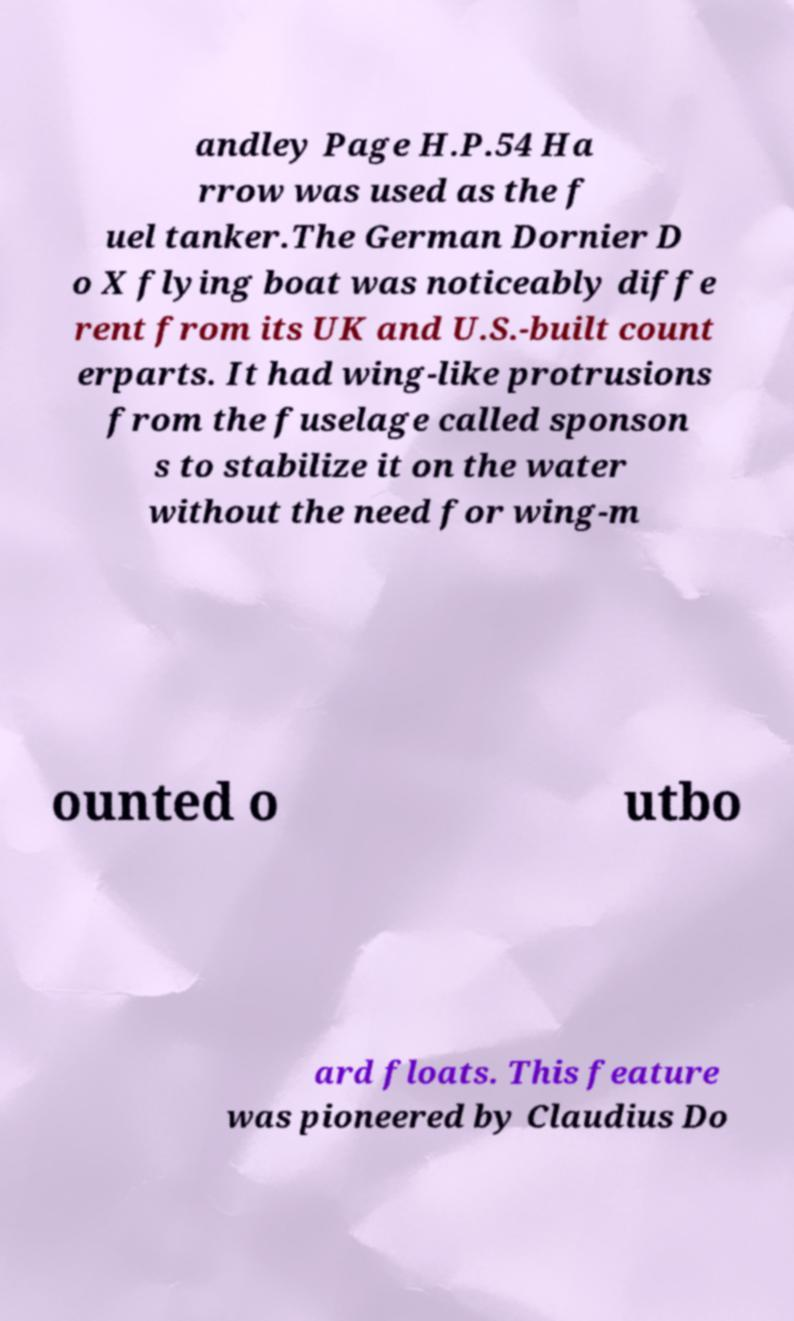Could you extract and type out the text from this image? andley Page H.P.54 Ha rrow was used as the f uel tanker.The German Dornier D o X flying boat was noticeably diffe rent from its UK and U.S.-built count erparts. It had wing-like protrusions from the fuselage called sponson s to stabilize it on the water without the need for wing-m ounted o utbo ard floats. This feature was pioneered by Claudius Do 